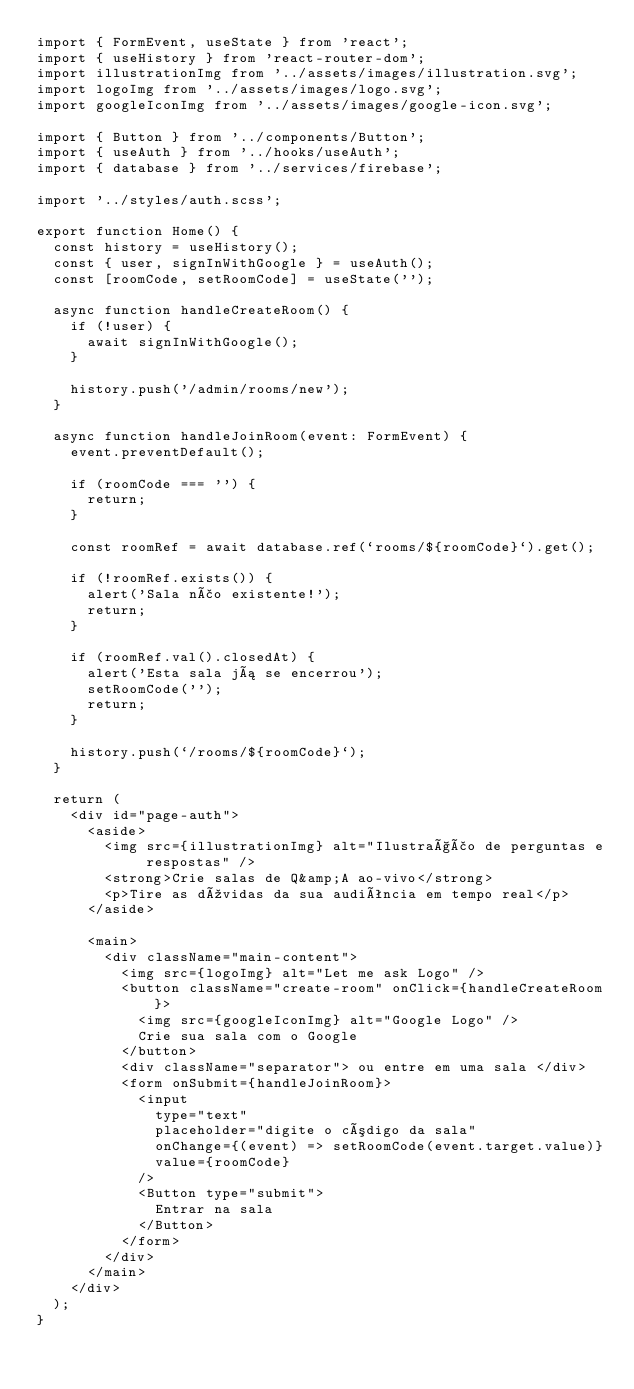Convert code to text. <code><loc_0><loc_0><loc_500><loc_500><_TypeScript_>import { FormEvent, useState } from 'react';
import { useHistory } from 'react-router-dom';
import illustrationImg from '../assets/images/illustration.svg';
import logoImg from '../assets/images/logo.svg';
import googleIconImg from '../assets/images/google-icon.svg';

import { Button } from '../components/Button';
import { useAuth } from '../hooks/useAuth';
import { database } from '../services/firebase';

import '../styles/auth.scss';

export function Home() {
  const history = useHistory();
  const { user, signInWithGoogle } = useAuth();
  const [roomCode, setRoomCode] = useState('');

  async function handleCreateRoom() {
    if (!user) {
      await signInWithGoogle();
    }

    history.push('/admin/rooms/new');
  }

  async function handleJoinRoom(event: FormEvent) {
    event.preventDefault();

    if (roomCode === '') {
      return;
    }

    const roomRef = await database.ref(`rooms/${roomCode}`).get();

    if (!roomRef.exists()) {
      alert('Sala não existente!');
      return;
    }

    if (roomRef.val().closedAt) {
      alert('Esta sala já se encerrou');
      setRoomCode('');
      return;
    }

    history.push(`/rooms/${roomCode}`);
  }

  return (
    <div id="page-auth">
      <aside>
        <img src={illustrationImg} alt="Ilustração de perguntas e respostas" />
        <strong>Crie salas de Q&amp;A ao-vivo</strong>
        <p>Tire as dúvidas da sua audiência em tempo real</p>
      </aside>

      <main>
        <div className="main-content">
          <img src={logoImg} alt="Let me ask Logo" />
          <button className="create-room" onClick={handleCreateRoom}>
            <img src={googleIconImg} alt="Google Logo" />
            Crie sua sala com o Google
          </button>
          <div className="separator"> ou entre em uma sala </div>
          <form onSubmit={handleJoinRoom}>
            <input
              type="text"
              placeholder="digite o código da sala"
              onChange={(event) => setRoomCode(event.target.value)}
              value={roomCode}
            />
            <Button type="submit">
              Entrar na sala
            </Button>
          </form>
        </div>
      </main>
    </div>
  );
}
</code> 